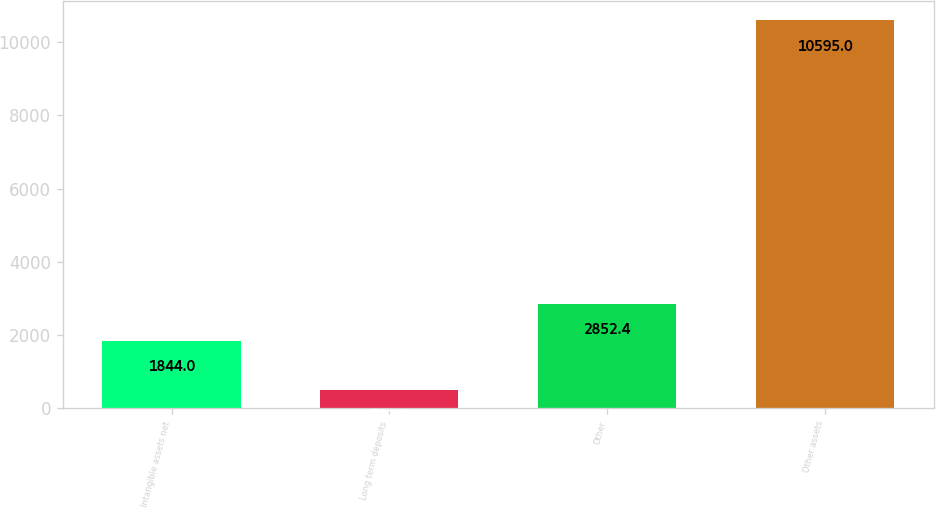Convert chart. <chart><loc_0><loc_0><loc_500><loc_500><bar_chart><fcel>Intangible assets net<fcel>Long term deposits<fcel>Other<fcel>Other assets<nl><fcel>1844<fcel>511<fcel>2852.4<fcel>10595<nl></chart> 